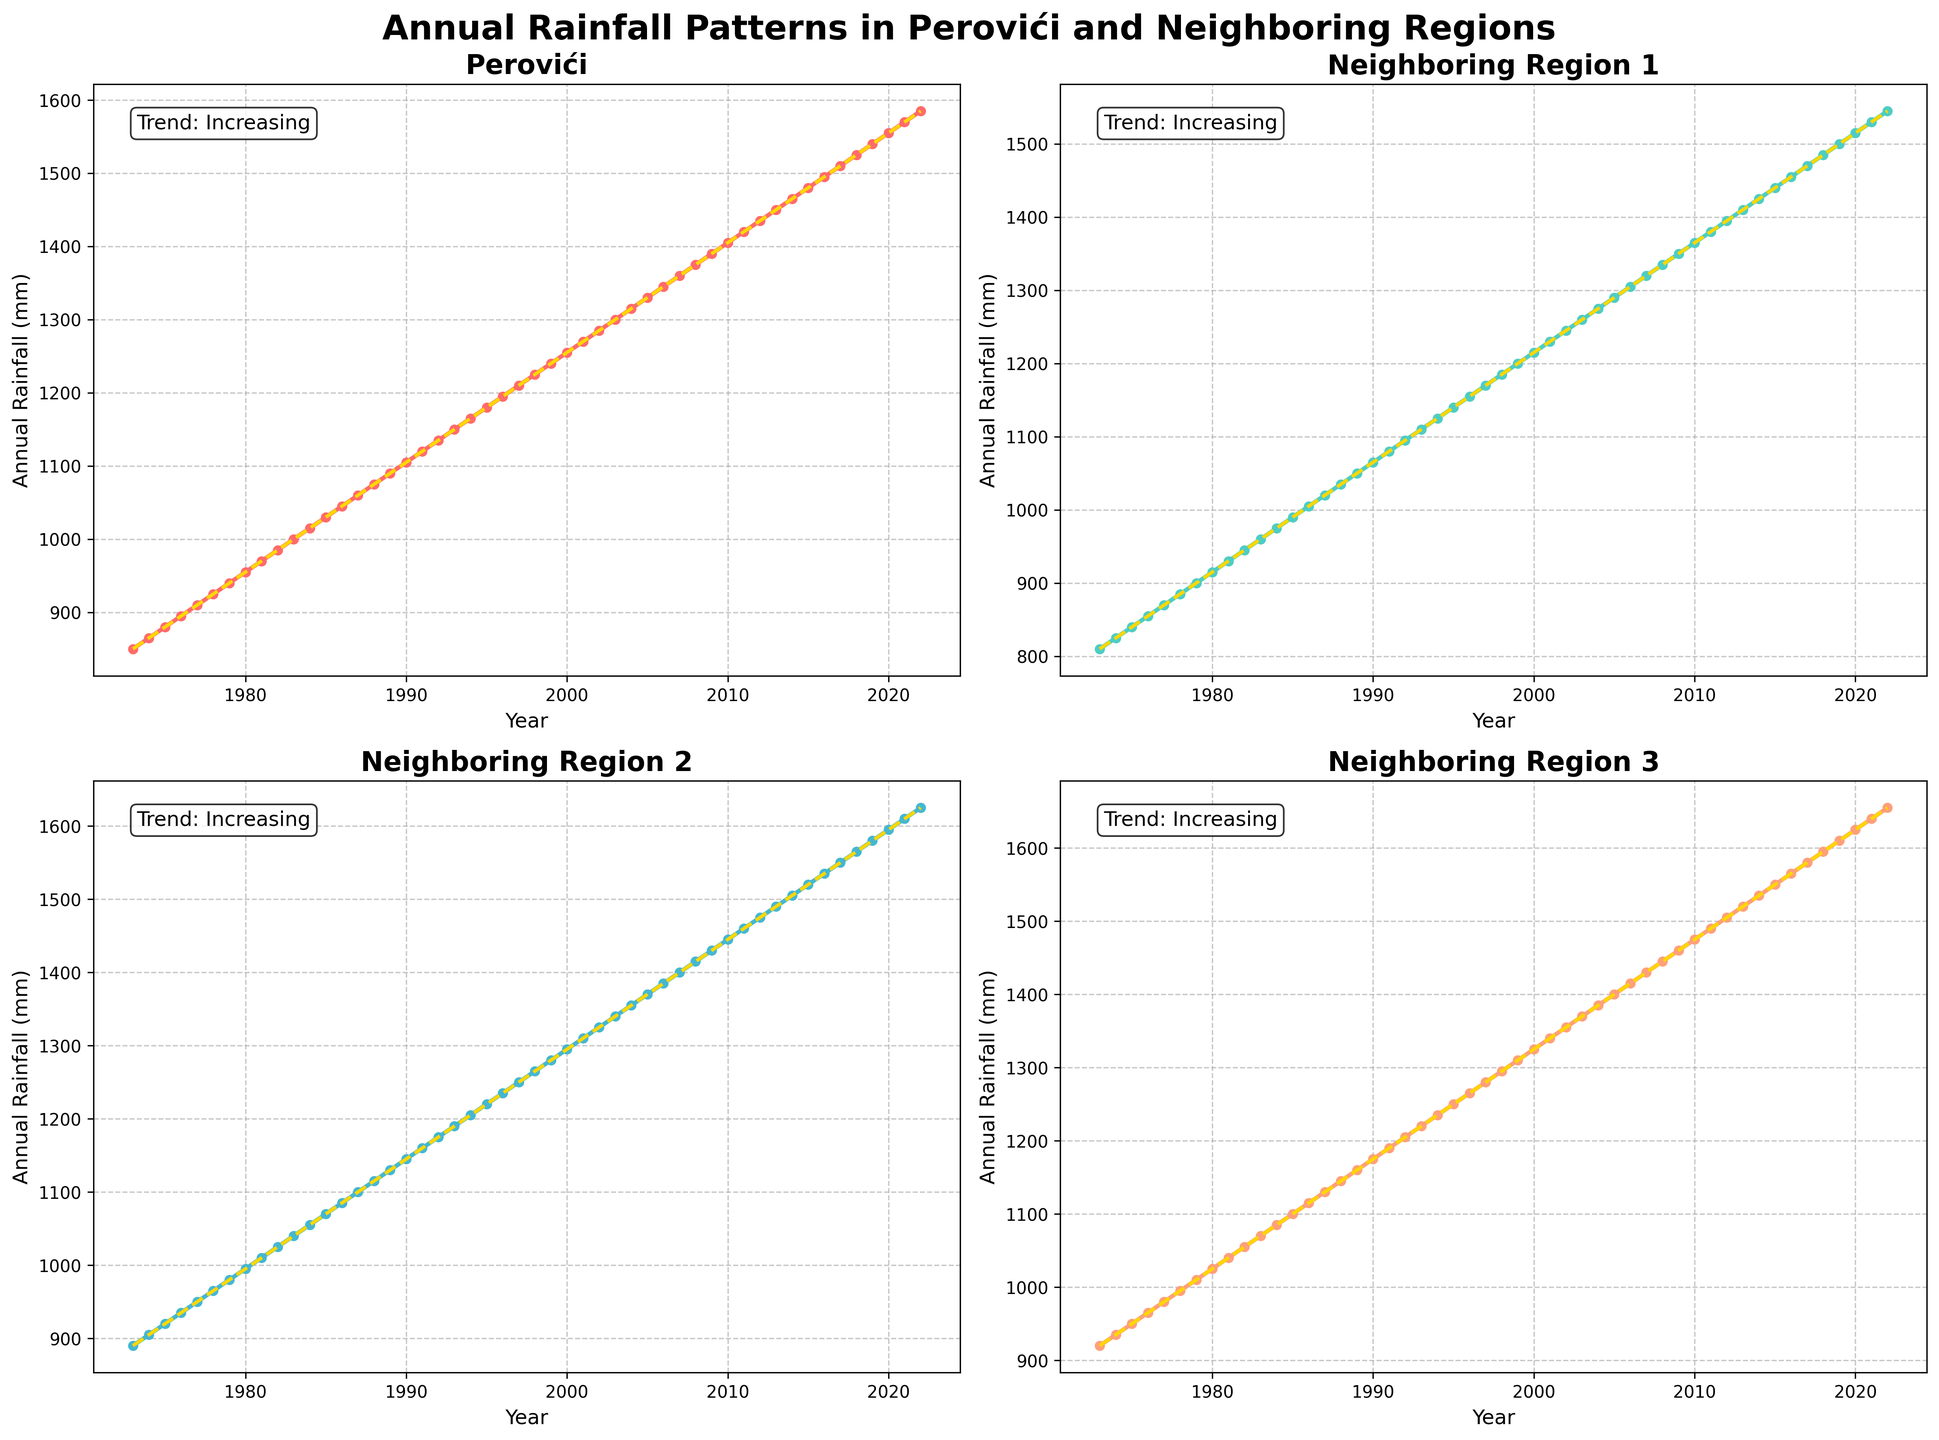What is the overall trend of annual rainfall in Perovići over the last 50 years? The subplot shows a line chart for Perovići with a trend line. The trend line's slope is positive, indicating an increasing trend over the years.
Answer: Increasing Which region had the highest annual rainfall in 2022? Looking at the graphs for 2022, Neighboring Region 3 has the highest value on the y-axis compared to Perovići, Neighboring Region 1, and Neighboring Region 2.
Answer: Neighboring Region 3 How does the average annual rainfall in Perovići from 2010 to 2022 compare to Neighboring Region 1 in the same period? Calculate the average annual rainfall for Perovići and Neighboring Region 1 using the provided data points from 2010 to 2022 and compare them. For Perovići, sum (1405 + 1420 + 1435 + 1450 + 1465 + 1480 + 1495 + 1510 + 1525 + 1540 + 1555 + 1570 + 1585) / 13. For Neighboring Region 1, sum (1365 + 1380 + 1395 + 1410 + 1425 + 1440 + 1455 + 1470 + 1485 + 1500 + 1515 + 1530 + 1545) / 13. Compare the two averages. Perovići's average: 1513, Neighboring Region 1's average: 1467.
Answer: Perovići has higher average annual rainfall What is the difference in annual rainfall between Perovići and Neighboring Region 2 for the year 1990? Focus on the year 1990 in both subplots and subtract the annual rainfall of Neighboring Region 2 (1145mm) from that of Perovići (1105mm). The difference is 1145 - 1105 = 40mm.
Answer: 40mm Which region shows the steepest increase in rainfall over the last 50 years? Assess the trend lines on all four subplots. A steeper line indicates a higher rate of increase. Neighboring Region 3’s trend line is the steepest, indicating the sharpest rise in rainfall.
Answer: Neighboring Region 3 In which year did Perovići first surpass 1300mm in annual rainfall? Observe the subplot for Perovići and trace the line to see where it first crosses the 1300mm mark on the y-axis. It happens in 2003.
Answer: 2003 How does the annual rainfall of Neighboring Region 1 in 1983 compare to that in 2015? Compare the y-values for Neighboring Region 1 in 1983 (960mm) and 2015 (1440mm). Subtract the former value from the latter. 1440 - 960 = 480mm.
Answer: 480mm more in 2015 What is the combined annual rainfall for Perovići and Neighboring Region 2 in 1978? Add the annual rainfall values for Perovići (925mm) and Neighboring Region 2 (965mm) in 1978. The sum is 925 + 965 = 1890mm.
Answer: 1890mm Which region showed an increasing trend but with a lower slope compared to Perovići? Comparing trend slopes in the subplots, Neighboring Region 1 shows an increasing trend (positive slope) but is less steep compared to Perovići.
Answer: Neighboring Region 1 